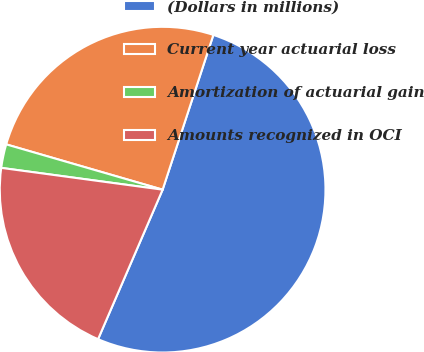Convert chart. <chart><loc_0><loc_0><loc_500><loc_500><pie_chart><fcel>(Dollars in millions)<fcel>Current year actuarial loss<fcel>Amortization of actuarial gain<fcel>Amounts recognized in OCI<nl><fcel>51.45%<fcel>25.56%<fcel>2.35%<fcel>20.65%<nl></chart> 